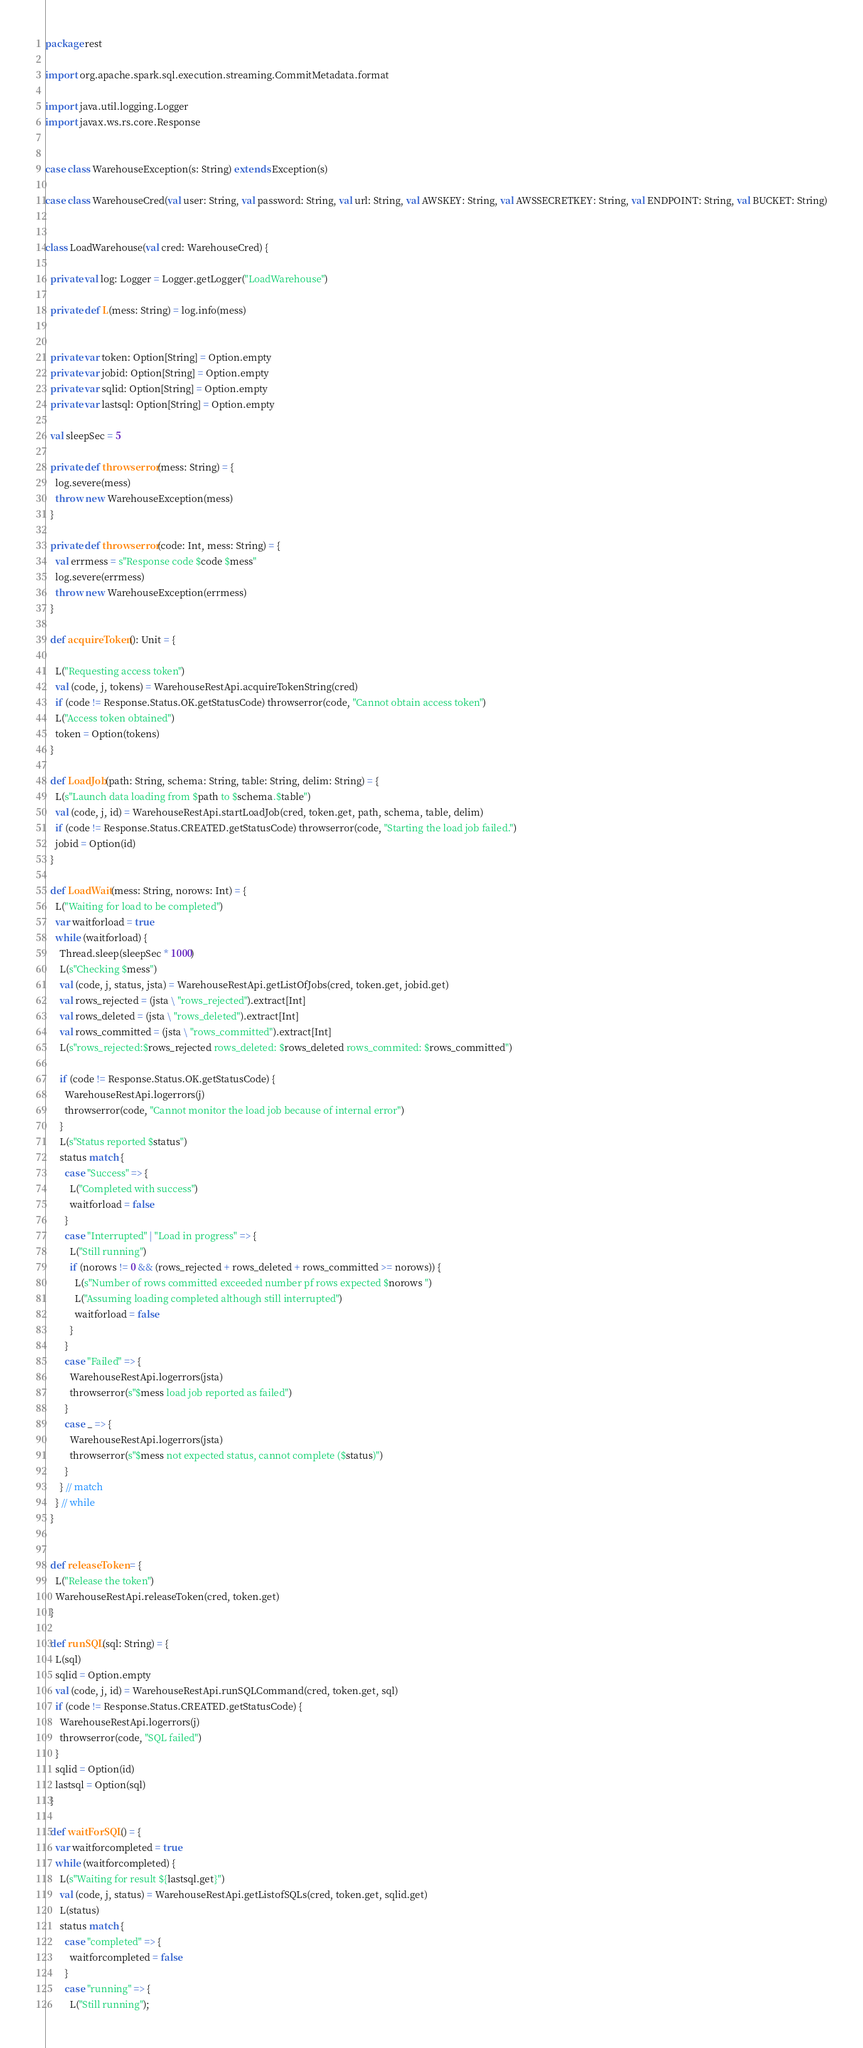Convert code to text. <code><loc_0><loc_0><loc_500><loc_500><_Scala_>package rest

import org.apache.spark.sql.execution.streaming.CommitMetadata.format

import java.util.logging.Logger
import javax.ws.rs.core.Response


case class WarehouseException(s: String) extends Exception(s)

case class WarehouseCred(val user: String, val password: String, val url: String, val AWSKEY: String, val AWSSECRETKEY: String, val ENDPOINT: String, val BUCKET: String)


class LoadWarehouse(val cred: WarehouseCred) {

  private val log: Logger = Logger.getLogger("LoadWarehouse")

  private def L(mess: String) = log.info(mess)


  private var token: Option[String] = Option.empty
  private var jobid: Option[String] = Option.empty
  private var sqlid: Option[String] = Option.empty
  private var lastsql: Option[String] = Option.empty

  val sleepSec = 5

  private def throwserror(mess: String) = {
    log.severe(mess)
    throw new WarehouseException(mess)
  }

  private def throwserror(code: Int, mess: String) = {
    val errmess = s"Response code $code $mess"
    log.severe(errmess)
    throw new WarehouseException(errmess)
  }

  def acquireToken(): Unit = {

    L("Requesting access token")
    val (code, j, tokens) = WarehouseRestApi.acquireTokenString(cred)
    if (code != Response.Status.OK.getStatusCode) throwserror(code, "Cannot obtain access token")
    L("Access token obtained")
    token = Option(tokens)
  }

  def LoadJob(path: String, schema: String, table: String, delim: String) = {
    L(s"Launch data loading from $path to $schema.$table")
    val (code, j, id) = WarehouseRestApi.startLoadJob(cred, token.get, path, schema, table, delim)
    if (code != Response.Status.CREATED.getStatusCode) throwserror(code, "Starting the load job failed.")
    jobid = Option(id)
  }

  def LoadWait(mess: String, norows: Int) = {
    L("Waiting for load to be completed")
    var waitforload = true
    while (waitforload) {
      Thread.sleep(sleepSec * 1000)
      L(s"Checking $mess")
      val (code, j, status, jsta) = WarehouseRestApi.getListOfJobs(cred, token.get, jobid.get)
      val rows_rejected = (jsta \ "rows_rejected").extract[Int]
      val rows_deleted = (jsta \ "rows_deleted").extract[Int]
      val rows_committed = (jsta \ "rows_committed").extract[Int]
      L(s"rows_rejected:$rows_rejected rows_deleted: $rows_deleted rows_commited: $rows_committed")

      if (code != Response.Status.OK.getStatusCode) {
        WarehouseRestApi.logerrors(j)
        throwserror(code, "Cannot monitor the load job because of internal error")
      }
      L(s"Status reported $status")
      status match {
        case "Success" => {
          L("Completed with success")
          waitforload = false
        }
        case "Interrupted" | "Load in progress" => {
          L("Still running")
          if (norows != 0 && (rows_rejected + rows_deleted + rows_committed >= norows)) {
            L(s"Number of rows committed exceeded number pf rows expected $norows ")
            L("Assuming loading completed although still interrupted")
            waitforload = false
          }
        }
        case "Failed" => {
          WarehouseRestApi.logerrors(jsta)
          throwserror(s"$mess load job reported as failed")
        }
        case _ => {
          WarehouseRestApi.logerrors(jsta)
          throwserror(s"$mess not expected status, cannot complete ($status)")
        }
      } // match
    } // while
  }


  def releaseToken = {
    L("Release the token")
    WarehouseRestApi.releaseToken(cred, token.get)
  }

  def runSQL(sql: String) = {
    L(sql)
    sqlid = Option.empty
    val (code, j, id) = WarehouseRestApi.runSQLCommand(cred, token.get, sql)
    if (code != Response.Status.CREATED.getStatusCode) {
      WarehouseRestApi.logerrors(j)
      throwserror(code, "SQL failed")
    }
    sqlid = Option(id)
    lastsql = Option(sql)
  }

  def waitForSQL() = {
    var waitforcompleted = true
    while (waitforcompleted) {
      L(s"Waiting for result ${lastsql.get}")
      val (code, j, status) = WarehouseRestApi.getListofSQLs(cred, token.get, sqlid.get)
      L(status)
      status match {
        case "completed" => {
          waitforcompleted = false
        }
        case "running" => {
          L("Still running");</code> 